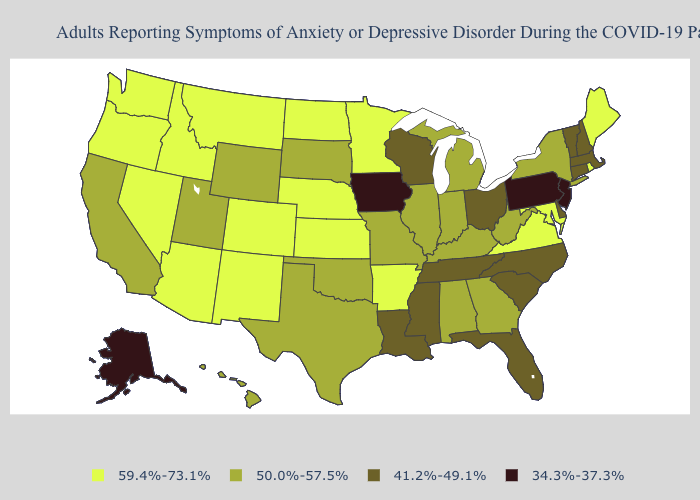Name the states that have a value in the range 50.0%-57.5%?
Write a very short answer. Alabama, California, Georgia, Hawaii, Illinois, Indiana, Kentucky, Michigan, Missouri, New York, Oklahoma, South Dakota, Texas, Utah, West Virginia, Wyoming. What is the value of North Dakota?
Write a very short answer. 59.4%-73.1%. Does New Jersey have a lower value than Iowa?
Answer briefly. No. What is the value of Missouri?
Quick response, please. 50.0%-57.5%. Among the states that border North Carolina , which have the highest value?
Give a very brief answer. Virginia. Name the states that have a value in the range 59.4%-73.1%?
Concise answer only. Arizona, Arkansas, Colorado, Idaho, Kansas, Maine, Maryland, Minnesota, Montana, Nebraska, Nevada, New Mexico, North Dakota, Oregon, Rhode Island, Virginia, Washington. Does Connecticut have a higher value than Ohio?
Short answer required. No. What is the value of Florida?
Be succinct. 41.2%-49.1%. Name the states that have a value in the range 50.0%-57.5%?
Short answer required. Alabama, California, Georgia, Hawaii, Illinois, Indiana, Kentucky, Michigan, Missouri, New York, Oklahoma, South Dakota, Texas, Utah, West Virginia, Wyoming. Does New Hampshire have the same value as Nevada?
Quick response, please. No. Name the states that have a value in the range 59.4%-73.1%?
Give a very brief answer. Arizona, Arkansas, Colorado, Idaho, Kansas, Maine, Maryland, Minnesota, Montana, Nebraska, Nevada, New Mexico, North Dakota, Oregon, Rhode Island, Virginia, Washington. Among the states that border Wyoming , does Montana have the lowest value?
Answer briefly. No. What is the value of Mississippi?
Write a very short answer. 41.2%-49.1%. Which states have the highest value in the USA?
Concise answer only. Arizona, Arkansas, Colorado, Idaho, Kansas, Maine, Maryland, Minnesota, Montana, Nebraska, Nevada, New Mexico, North Dakota, Oregon, Rhode Island, Virginia, Washington. How many symbols are there in the legend?
Keep it brief. 4. 